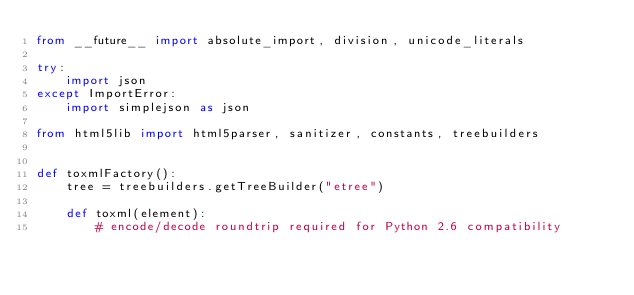<code> <loc_0><loc_0><loc_500><loc_500><_Python_>from __future__ import absolute_import, division, unicode_literals

try:
    import json
except ImportError:
    import simplejson as json

from html5lib import html5parser, sanitizer, constants, treebuilders


def toxmlFactory():
    tree = treebuilders.getTreeBuilder("etree")

    def toxml(element):
        # encode/decode roundtrip required for Python 2.6 compatibility</code> 